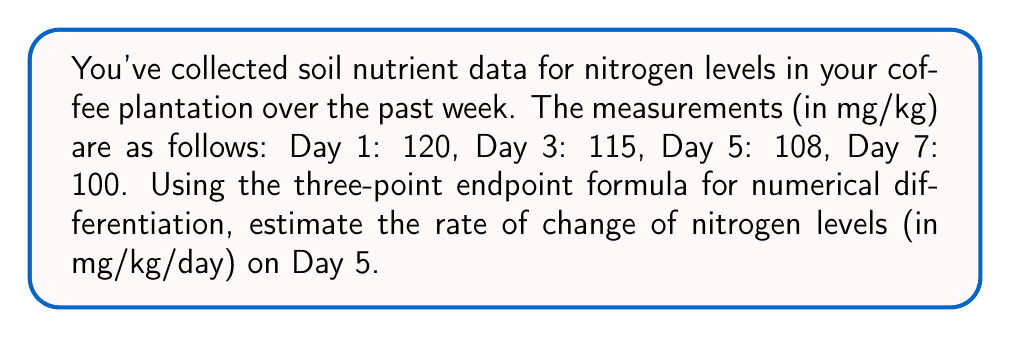Provide a solution to this math problem. To solve this problem, we'll use the three-point endpoint formula for numerical differentiation. This formula estimates the derivative at a point using three data points.

The formula is:

$$ f'(x_1) \approx \frac{-3f(x_0) + 4f(x_1) - f(x_2)}{2h} $$

Where:
- $x_0$, $x_1$, and $x_2$ are three consecutive points
- $h$ is the step size between points

Step 1: Identify our data points
$x_0 = 3$, $f(x_0) = 115$
$x_1 = 5$, $f(x_1) = 108$
$x_2 = 7$, $f(x_2) = 100$

Step 2: Calculate the step size $h$
$h = x_1 - x_0 = 5 - 3 = 2$ days

Step 3: Apply the formula
$$ f'(5) \approx \frac{-3(115) + 4(108) - 100}{2(2)} $$

Step 4: Simplify
$$ f'(5) \approx \frac{-345 + 432 - 100}{4} = \frac{-13}{4} = -3.25 $$

Therefore, the estimated rate of change of nitrogen levels on Day 5 is -3.25 mg/kg/day.
Answer: -3.25 mg/kg/day 